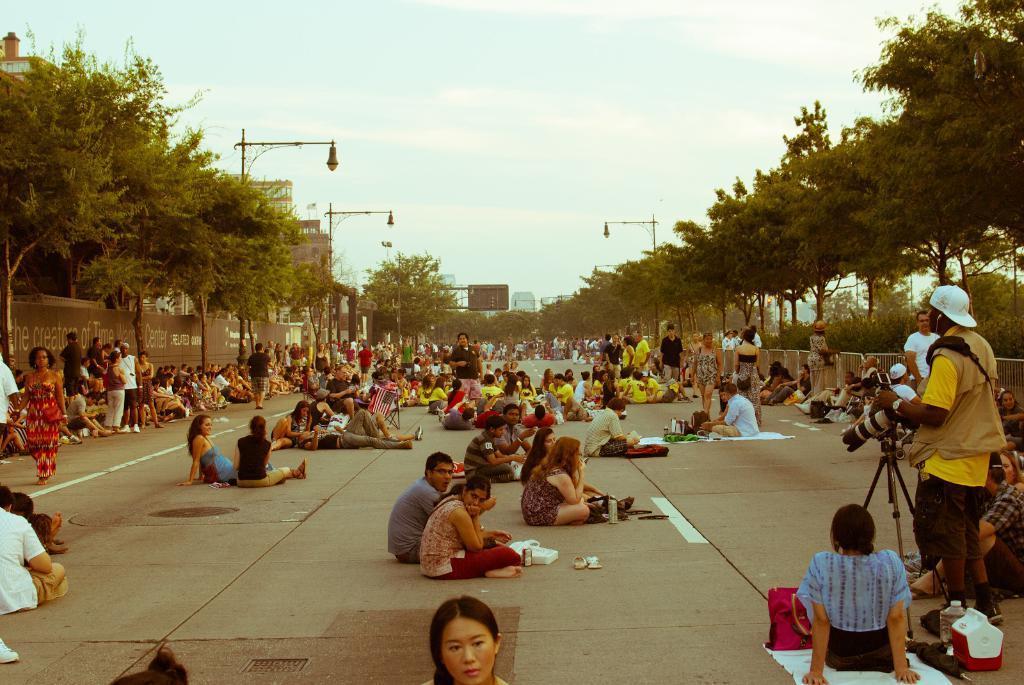Please provide a concise description of this image. In this image there are group of people some of them are sitting and some of them are standing, and at the bottom there is a walkway and also we could see some baskets, bottles, clothes, handbags, cups and some other objects. On the right side there is one person who is holding a camera, and on the right side and left side there are trees, wall, poles, light and buildings and at the top there is sky. 